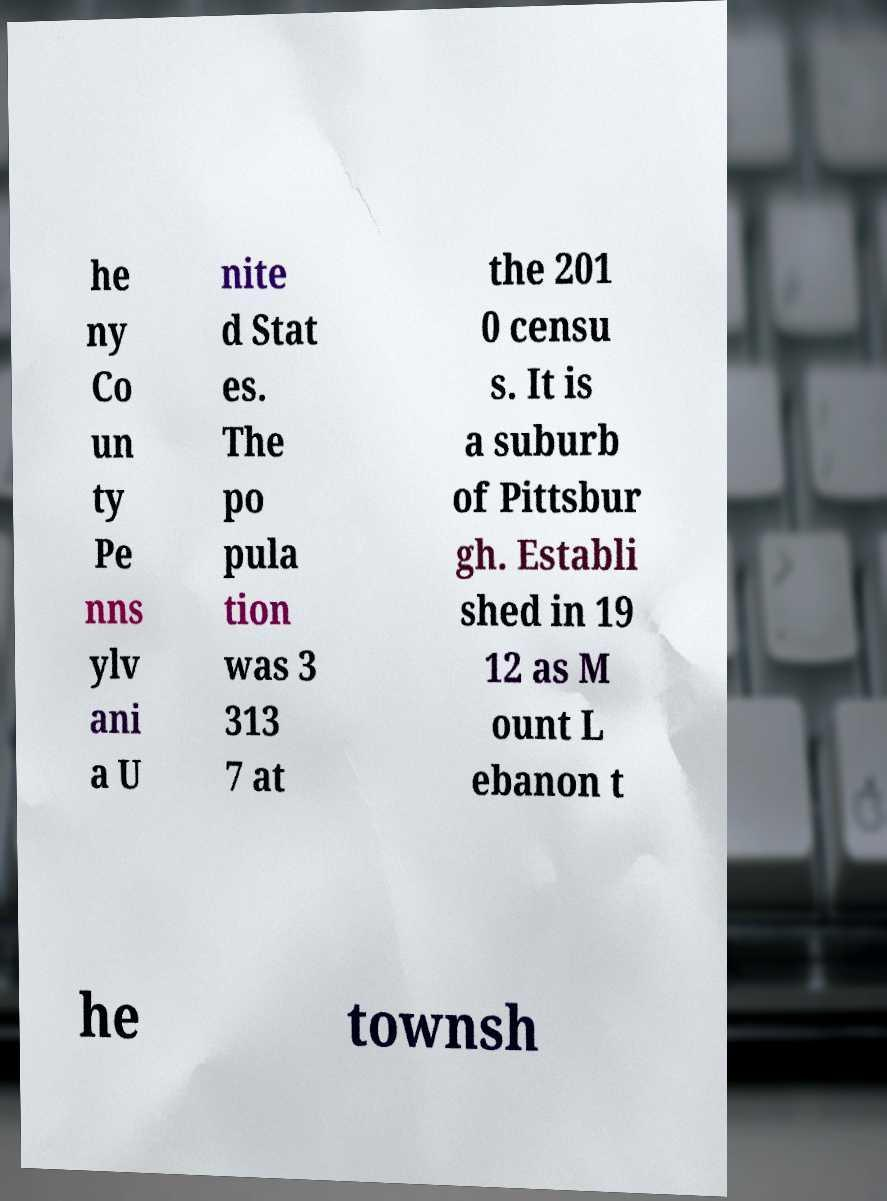Please read and relay the text visible in this image. What does it say? he ny Co un ty Pe nns ylv ani a U nite d Stat es. The po pula tion was 3 313 7 at the 201 0 censu s. It is a suburb of Pittsbur gh. Establi shed in 19 12 as M ount L ebanon t he townsh 